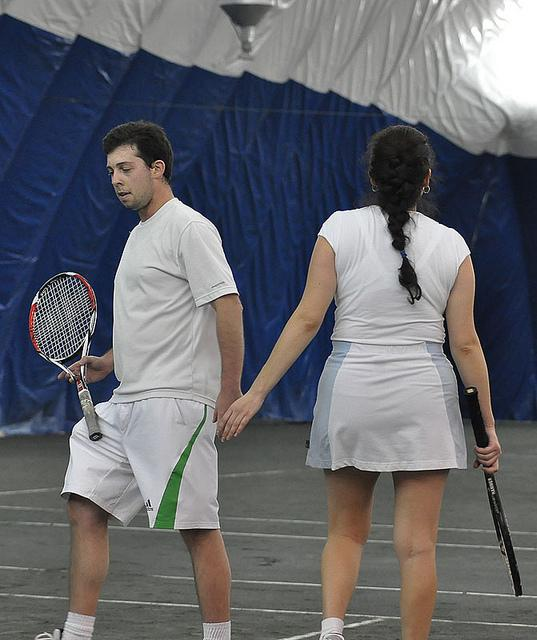What is making the man's pocket pop up?

Choices:
A) billiard balls
B) meat balls
C) bouncy balls
D) tennis balls tennis balls 